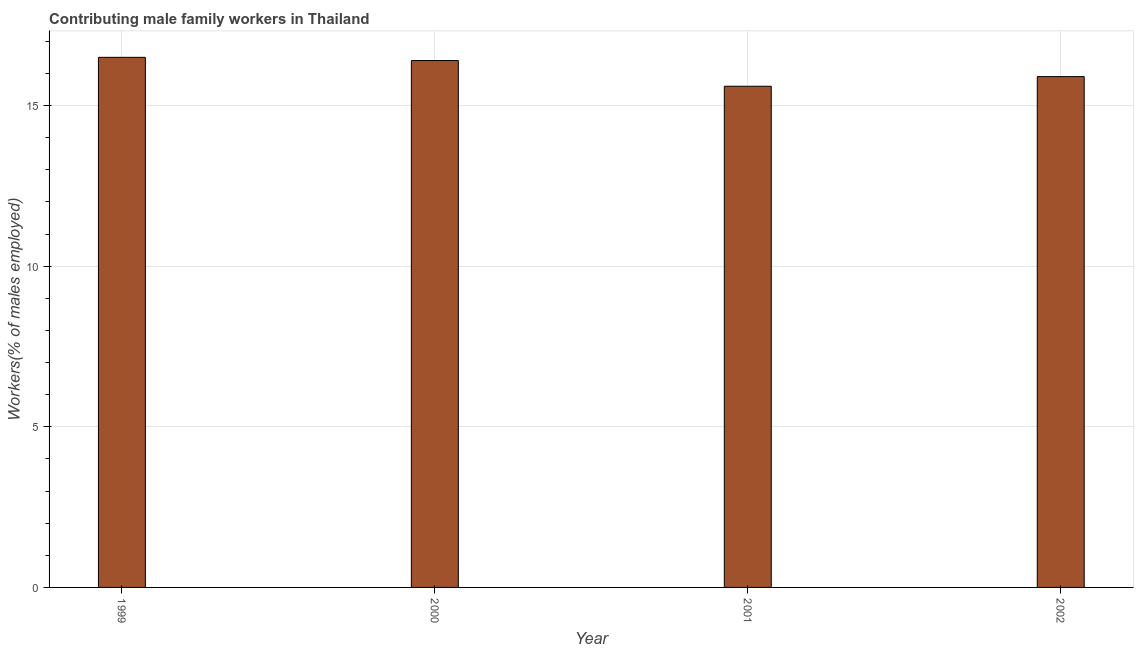Does the graph contain any zero values?
Ensure brevity in your answer.  No. Does the graph contain grids?
Ensure brevity in your answer.  Yes. What is the title of the graph?
Make the answer very short. Contributing male family workers in Thailand. What is the label or title of the X-axis?
Provide a succinct answer. Year. What is the label or title of the Y-axis?
Provide a short and direct response. Workers(% of males employed). Across all years, what is the minimum contributing male family workers?
Provide a short and direct response. 15.6. In which year was the contributing male family workers minimum?
Ensure brevity in your answer.  2001. What is the sum of the contributing male family workers?
Ensure brevity in your answer.  64.4. What is the median contributing male family workers?
Offer a terse response. 16.15. What is the ratio of the contributing male family workers in 1999 to that in 2001?
Ensure brevity in your answer.  1.06. Is the contributing male family workers in 1999 less than that in 2000?
Give a very brief answer. No. Is the difference between the contributing male family workers in 1999 and 2002 greater than the difference between any two years?
Keep it short and to the point. No. Is the sum of the contributing male family workers in 1999 and 2001 greater than the maximum contributing male family workers across all years?
Provide a short and direct response. Yes. In how many years, is the contributing male family workers greater than the average contributing male family workers taken over all years?
Give a very brief answer. 2. How many bars are there?
Keep it short and to the point. 4. How many years are there in the graph?
Give a very brief answer. 4. What is the difference between two consecutive major ticks on the Y-axis?
Offer a terse response. 5. What is the Workers(% of males employed) of 1999?
Provide a short and direct response. 16.5. What is the Workers(% of males employed) of 2000?
Offer a terse response. 16.4. What is the Workers(% of males employed) of 2001?
Offer a very short reply. 15.6. What is the Workers(% of males employed) of 2002?
Offer a very short reply. 15.9. What is the difference between the Workers(% of males employed) in 1999 and 2002?
Your answer should be compact. 0.6. What is the difference between the Workers(% of males employed) in 2000 and 2001?
Make the answer very short. 0.8. What is the difference between the Workers(% of males employed) in 2000 and 2002?
Ensure brevity in your answer.  0.5. What is the difference between the Workers(% of males employed) in 2001 and 2002?
Give a very brief answer. -0.3. What is the ratio of the Workers(% of males employed) in 1999 to that in 2001?
Make the answer very short. 1.06. What is the ratio of the Workers(% of males employed) in 1999 to that in 2002?
Your answer should be very brief. 1.04. What is the ratio of the Workers(% of males employed) in 2000 to that in 2001?
Offer a terse response. 1.05. What is the ratio of the Workers(% of males employed) in 2000 to that in 2002?
Offer a terse response. 1.03. What is the ratio of the Workers(% of males employed) in 2001 to that in 2002?
Provide a short and direct response. 0.98. 